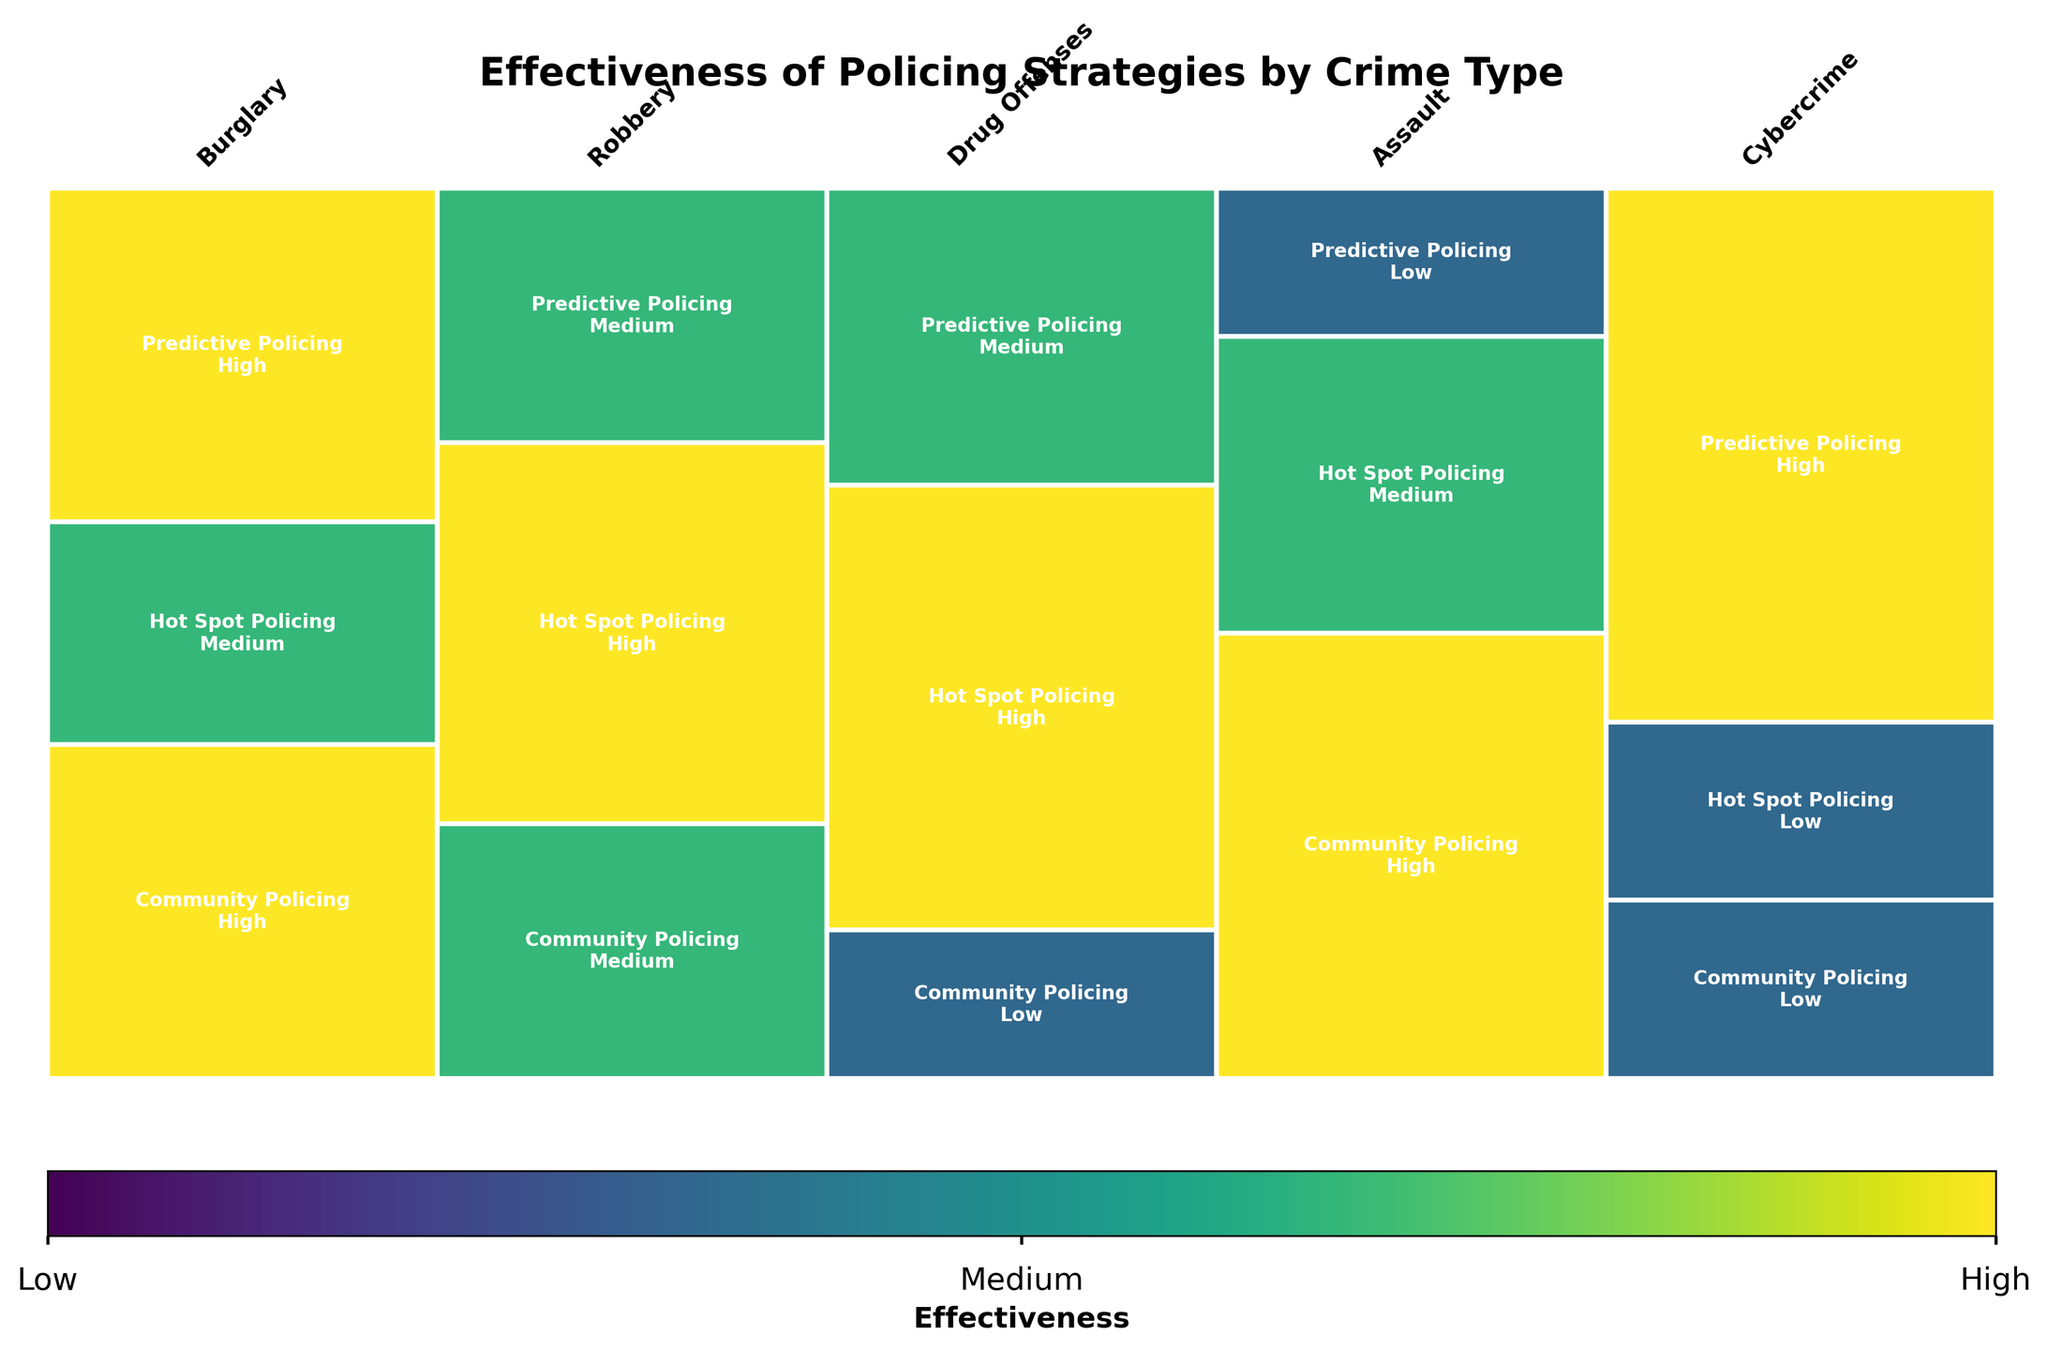What is the title of the plot? The title is displayed at the top of the plot, in a larger and bold font, and reads "Effectiveness of Policing Strategies by Crime Type."
Answer: Effectiveness of Policing Strategies by Crime Type How many crime types are represented in the plot? Each crime type is labeled above the relevant section of the plot, and there are five distinct labels: Burglary, Robbery, Drug Offenses, Assault, and Cybercrime.
Answer: 5 Which policing strategy is depicted as most effective in reducing drug offenses? By observing the section of the plot labeled "Drug Offenses," we see that the rectangle representing "Hot Spot Policing" reaches the highest position, indicating it has the highest effectiveness score.
Answer: Hot Spot Policing How does the effectiveness of Community Policing compare between Burglary and Cybercrime? Community Policing for Burglary is shown as "High," with its rectangle covering almost the entire height of the Burglary section, while for Cybercrime, it is labeled "Low," with a much smaller rectangle.
Answer: More effective for Burglary What is the total number of strategies evaluated for each crime type? Each column, representing a crime type, contains three separated rectangles, suggesting that three different strategies were evaluated for each crime type.
Answer: 3 Which policing strategy shows "Low" effectiveness for Assault? For the section labeled "Assault," we see that the "Predictive Policing" rectangle is the smallest and labeled "Low."
Answer: Predictive Policing What is the common effectiveness rating among Hot Spot Policing for Burglary and Cybercrime? In the plot sections for Burglary and Cybercrime, the rectangles labeled "Hot Spot Policing" show "Medium" and "Low" effectiveness, respectively, so there isn't a common rating.
Answer: None Which crime type has the most effectiveness rated as "Low" for all policing strategies? The plot section for Cybercrime shows that Community Policing and Hot Spot Policing both have a "Low" effectiveness rating.
Answer: Cybercrime 